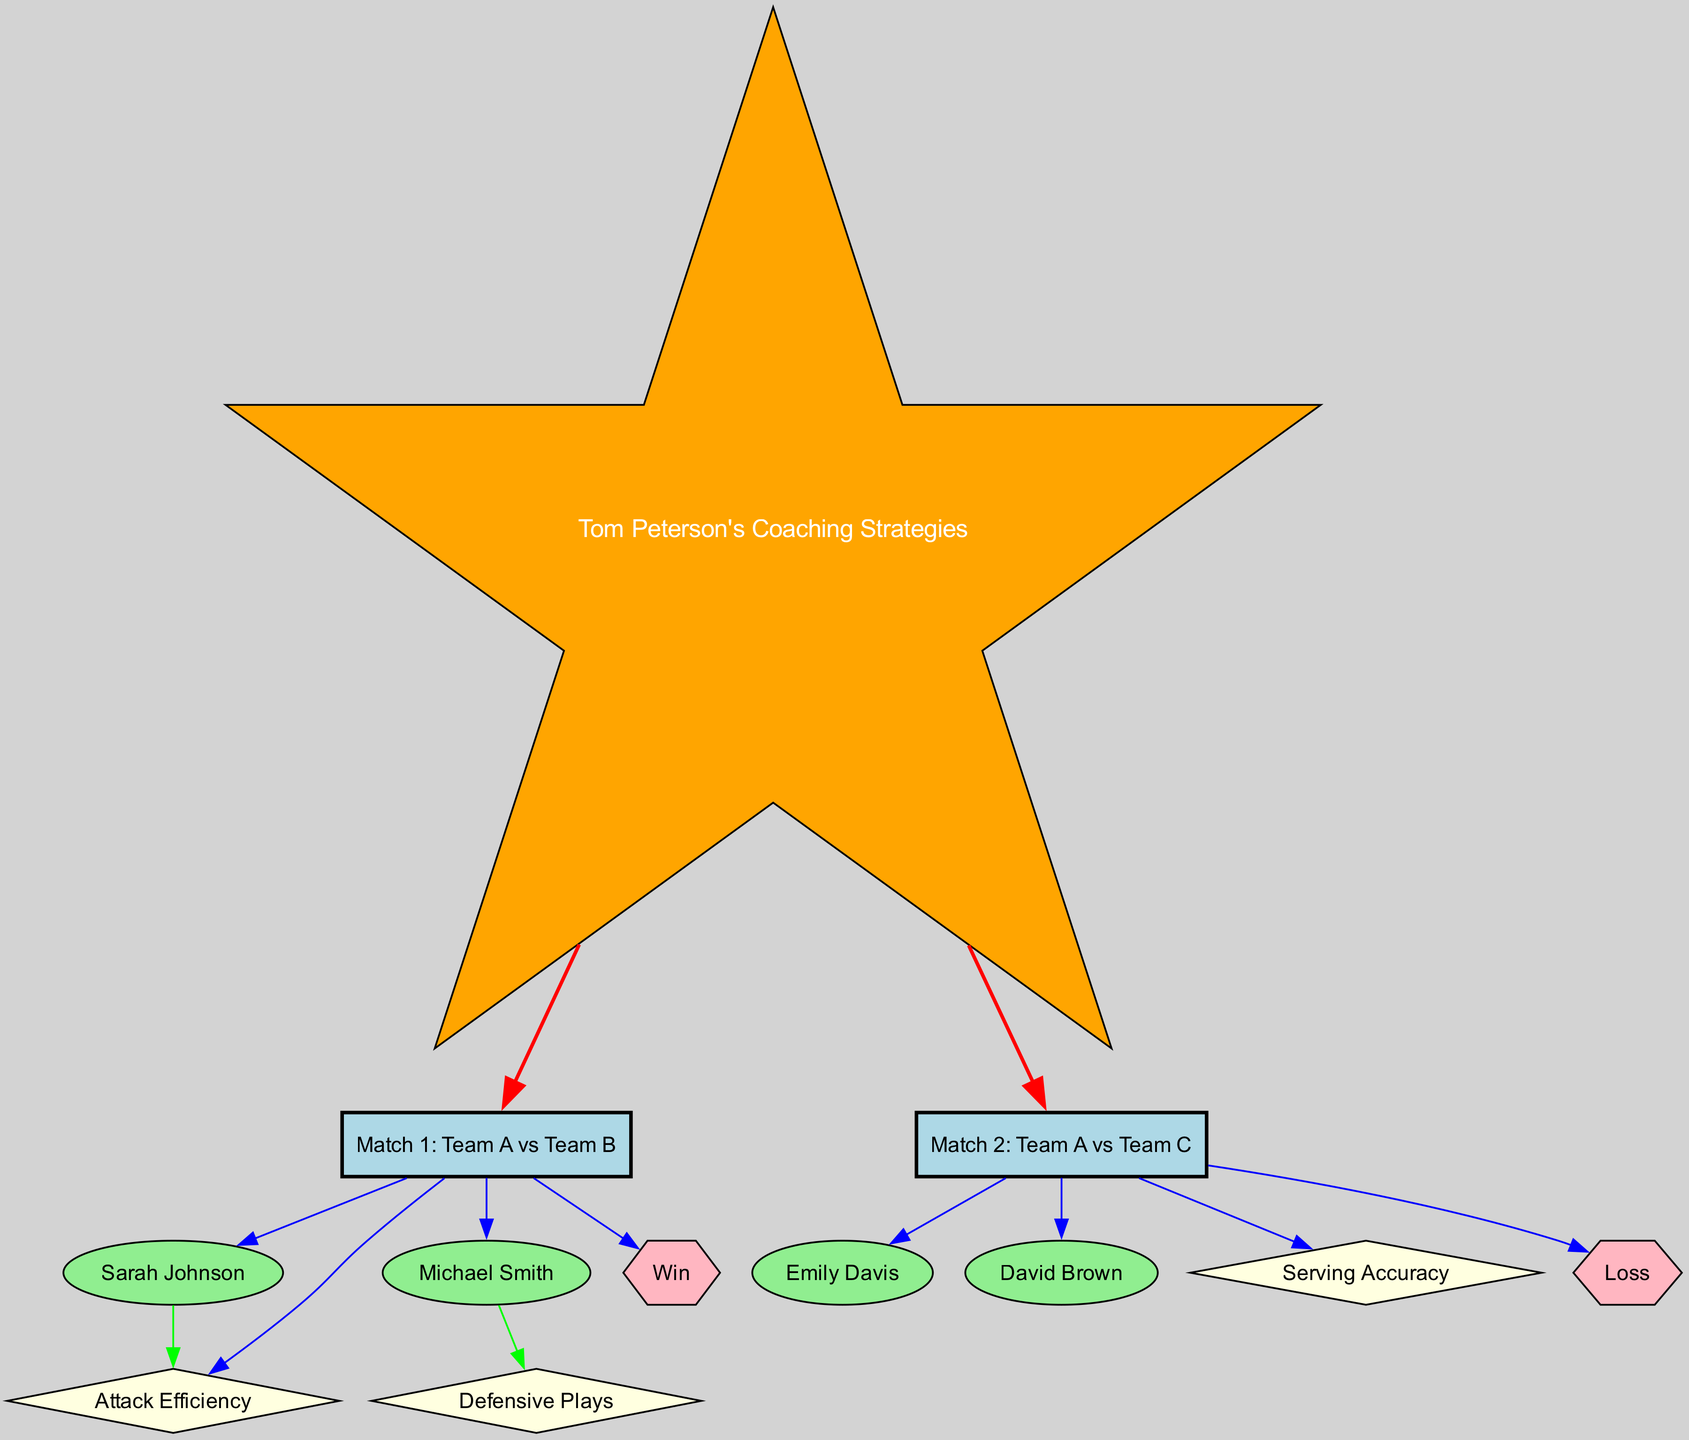What teams played in Match 1? The diagram shows that Match 1 involves Team A and Team B, as depicted by the label "Match 1: Team A vs Team B."
Answer: Team A and Team B Who were the players involved in Match 2? The diagram indicates that Match 2 involved players Emily Davis and David Brown, who are linked directly to Match 2.
Answer: Emily Davis and David Brown What is the performance type linked to Sarah Johnson? The diagram indicates that Sarah Johnson is associated with Attack Efficiency, connected directly from her node to the Node representing Attack Efficiency.
Answer: Attack Efficiency How many matches are represented in the diagram? By counting the match nodes in the diagram, there are a total of two matches depicted, represented by Match 1 and Match 2.
Answer: 2 Which performance metric is associated with Michael Smith? The diagram connects Michael Smith to Defensive Plays, which indicates the performance metric linked to him through the graph structure.
Answer: Defensive Plays What was the result of Match 2? The graph shows that the result of Match 2 is represented by the Loss node, which is connected directly to Match 2.
Answer: Loss How many players are linked to Match 1? The diagram shows two players, Sarah Johnson and Michael Smith, both of whom are connected to Match 1, representing the number of players involved.
Answer: 2 What coaching strategies does Tom Peterson use for Match 1? From the diagram, it indicates that Tom Peterson's coaching strategies are directly associated with both Match 1 and Match 2 as stated.
Answer: Tom Peterson's Coaching Strategies What is the connection type from Coach to the matches? The diagram indicates that the edges from Coach to the matches are colored red, which represents the coaching influence on both Match 1 and Match 2.
Answer: Coaching influence 